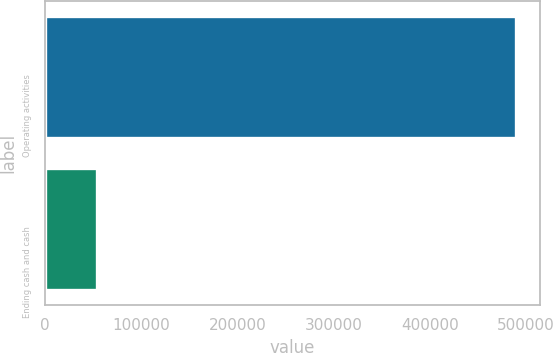<chart> <loc_0><loc_0><loc_500><loc_500><bar_chart><fcel>Operating activities<fcel>Ending cash and cash<nl><fcel>490025<fcel>54348<nl></chart> 